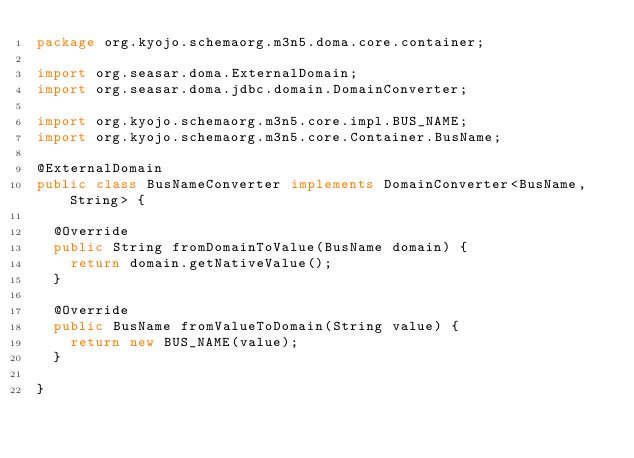Convert code to text. <code><loc_0><loc_0><loc_500><loc_500><_Java_>package org.kyojo.schemaorg.m3n5.doma.core.container;

import org.seasar.doma.ExternalDomain;
import org.seasar.doma.jdbc.domain.DomainConverter;

import org.kyojo.schemaorg.m3n5.core.impl.BUS_NAME;
import org.kyojo.schemaorg.m3n5.core.Container.BusName;

@ExternalDomain
public class BusNameConverter implements DomainConverter<BusName, String> {

	@Override
	public String fromDomainToValue(BusName domain) {
		return domain.getNativeValue();
	}

	@Override
	public BusName fromValueToDomain(String value) {
		return new BUS_NAME(value);
	}

}
</code> 